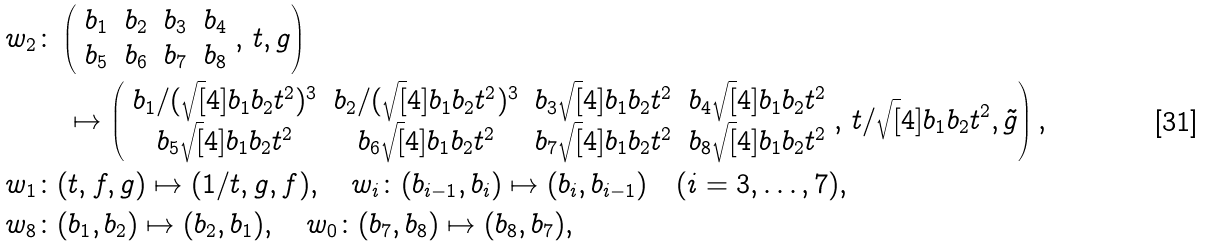<formula> <loc_0><loc_0><loc_500><loc_500>w _ { 2 } & \colon \left ( \begin{array} { c c c c } b _ { 1 } & b _ { 2 } & b _ { 3 } & b _ { 4 } \\ b _ { 5 } & b _ { 6 } & b _ { 7 } & b _ { 8 } \end{array} , \, t , g \right ) \\ & \quad \mapsto \left ( \begin{array} { c c c c } b _ { 1 } / ( \sqrt { [ } 4 ] { b _ { 1 } b _ { 2 } t ^ { 2 } } ) ^ { 3 } & b _ { 2 } / ( \sqrt { [ } 4 ] { b _ { 1 } b _ { 2 } t ^ { 2 } } ) ^ { 3 } & b _ { 3 } \sqrt { [ } 4 ] { b _ { 1 } b _ { 2 } t ^ { 2 } } & b _ { 4 } \sqrt { [ } 4 ] { b _ { 1 } b _ { 2 } t ^ { 2 } } \\ b _ { 5 } \sqrt { [ } 4 ] { b _ { 1 } b _ { 2 } t ^ { 2 } } & b _ { 6 } \sqrt { [ } 4 ] { b _ { 1 } b _ { 2 } t ^ { 2 } } & b _ { 7 } \sqrt { [ } 4 ] { b _ { 1 } b _ { 2 } t ^ { 2 } } & b _ { 8 } \sqrt { [ } 4 ] { b _ { 1 } b _ { 2 } t ^ { 2 } } \end{array} , \, t / \sqrt { [ } 4 ] { b _ { 1 } b _ { 2 } t ^ { 2 } } , \tilde { g } \right ) , \\ w _ { 1 } & \colon ( t , f , g ) \mapsto ( 1 / t , g , f ) , \quad w _ { i } \colon ( b _ { i - 1 } , b _ { i } ) \mapsto ( b _ { i } , b _ { i - 1 } ) \quad ( i = 3 , \dots , 7 ) , \\ w _ { 8 } & \colon ( b _ { 1 } , b _ { 2 } ) \mapsto ( b _ { 2 } , b _ { 1 } ) , \quad w _ { 0 } \colon ( b _ { 7 } , b _ { 8 } ) \mapsto ( b _ { 8 } , b _ { 7 } ) ,</formula> 